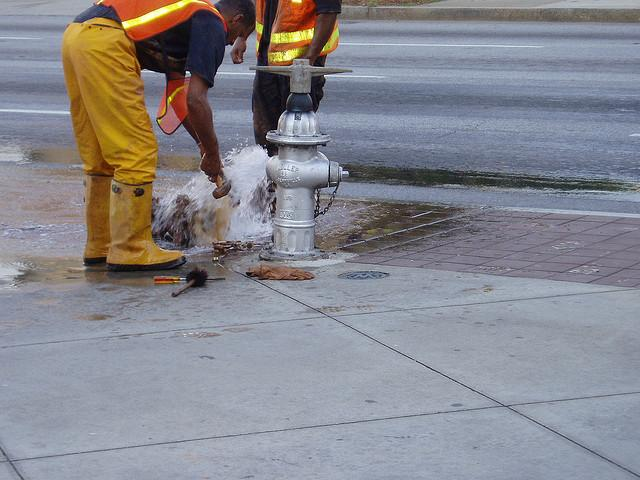Who is paying the person with the hammer? Please explain your reasoning. city. This is usually the case. 